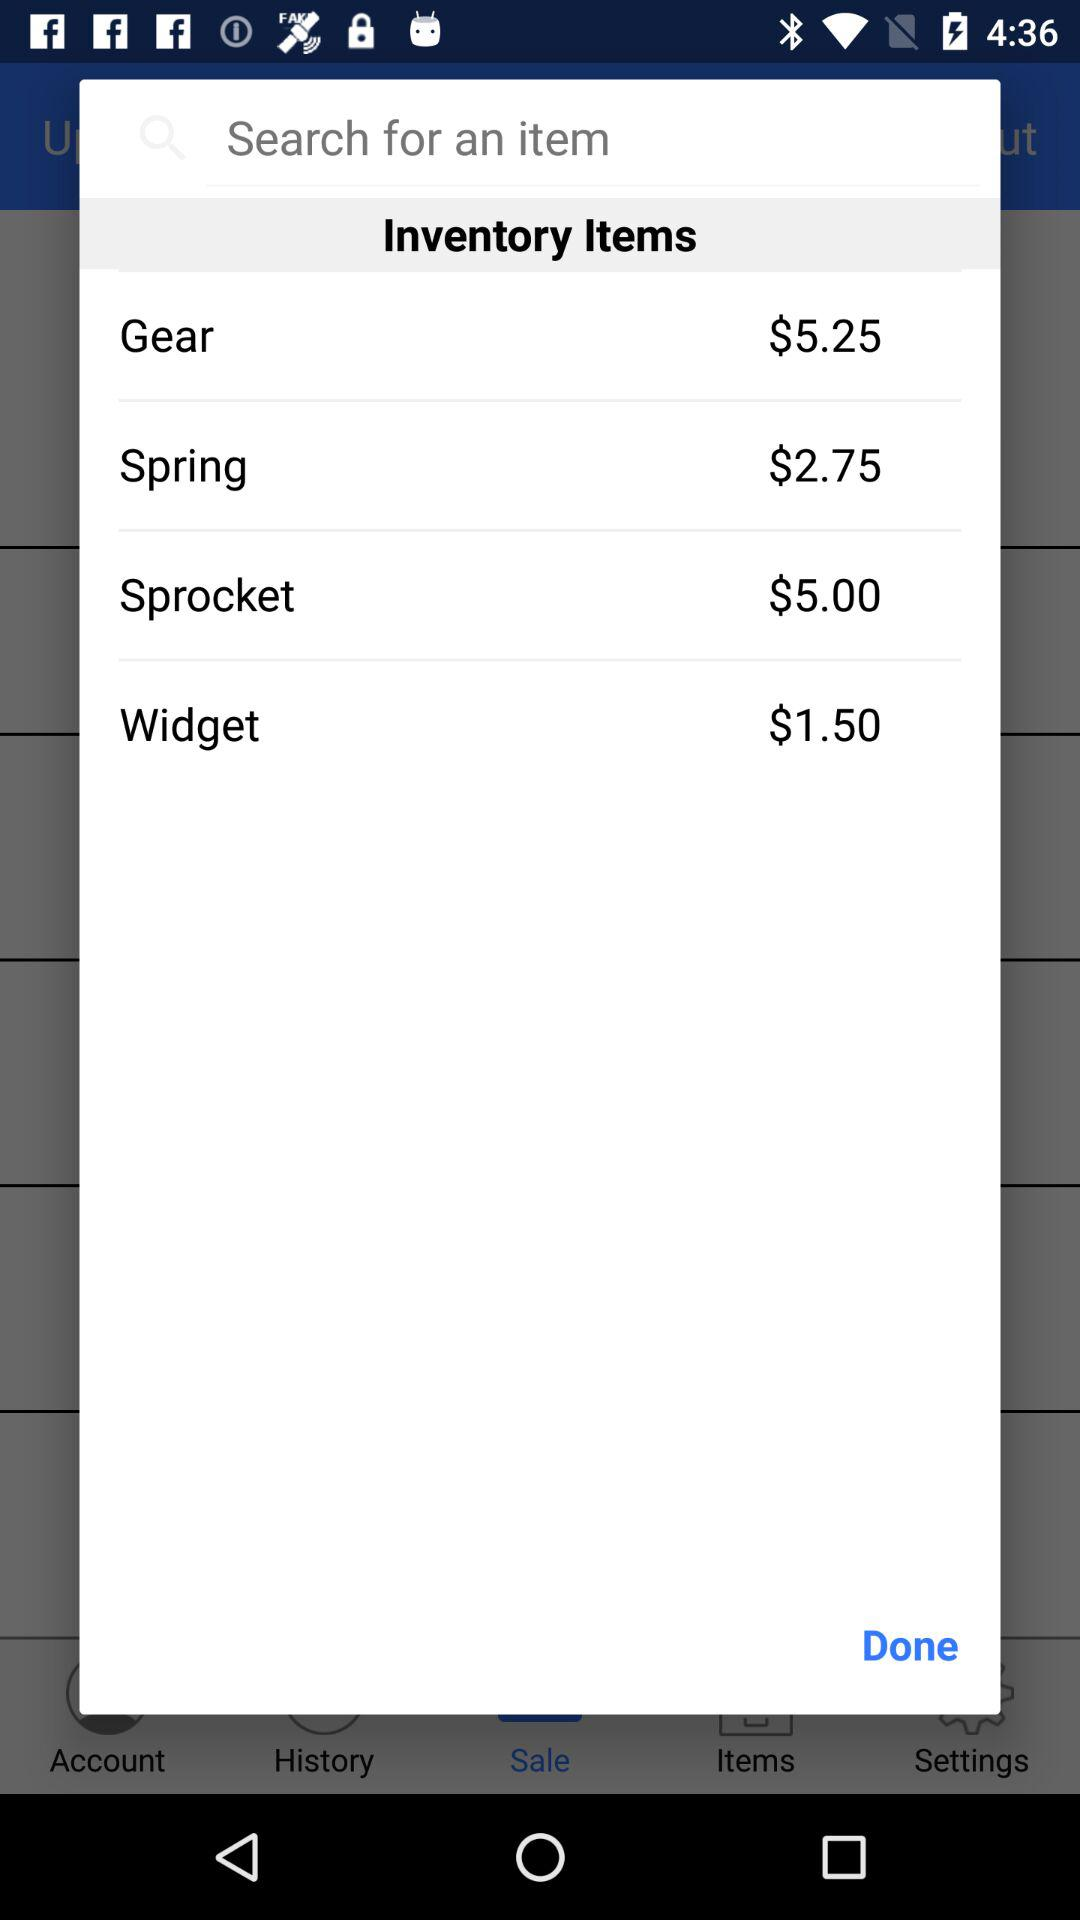What is the total price of the items in the inventory?
Answer the question using a single word or phrase. $14.50 